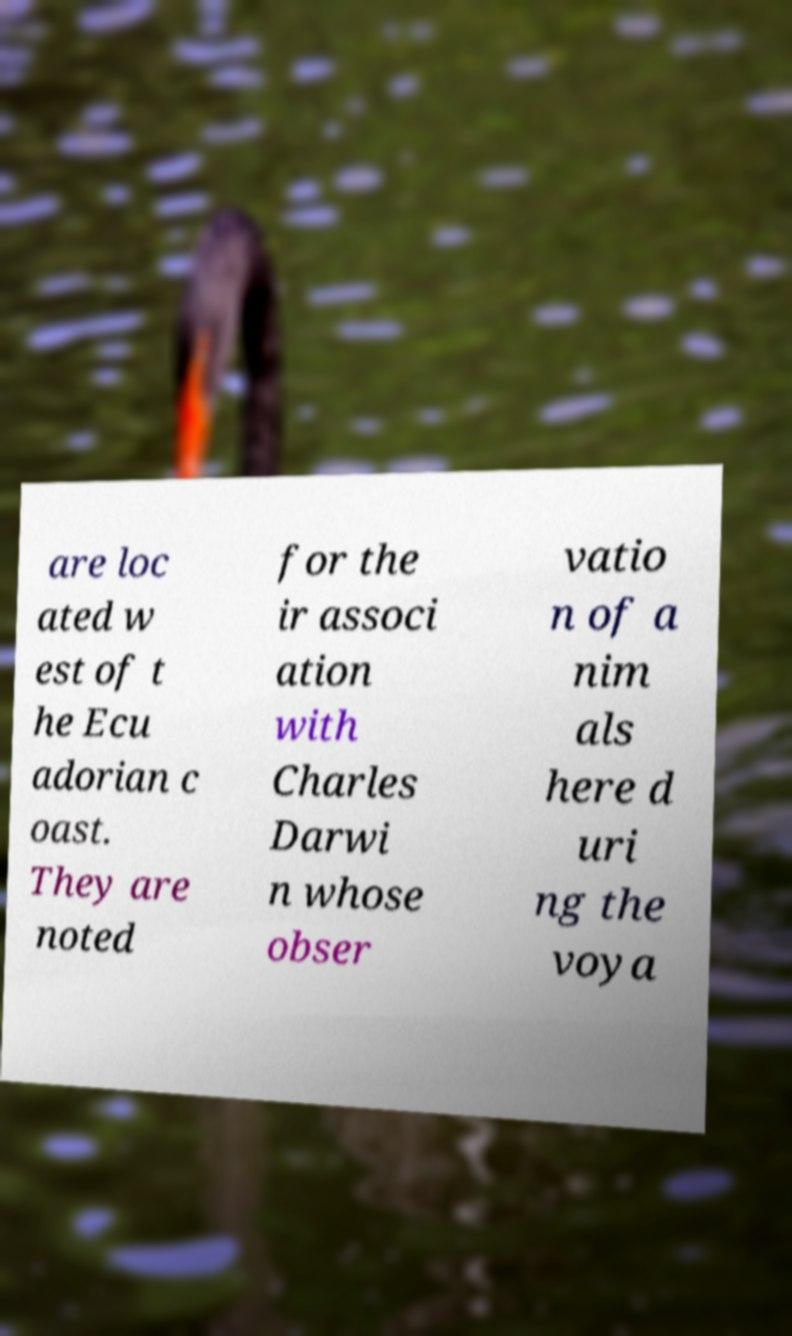Could you assist in decoding the text presented in this image and type it out clearly? are loc ated w est of t he Ecu adorian c oast. They are noted for the ir associ ation with Charles Darwi n whose obser vatio n of a nim als here d uri ng the voya 